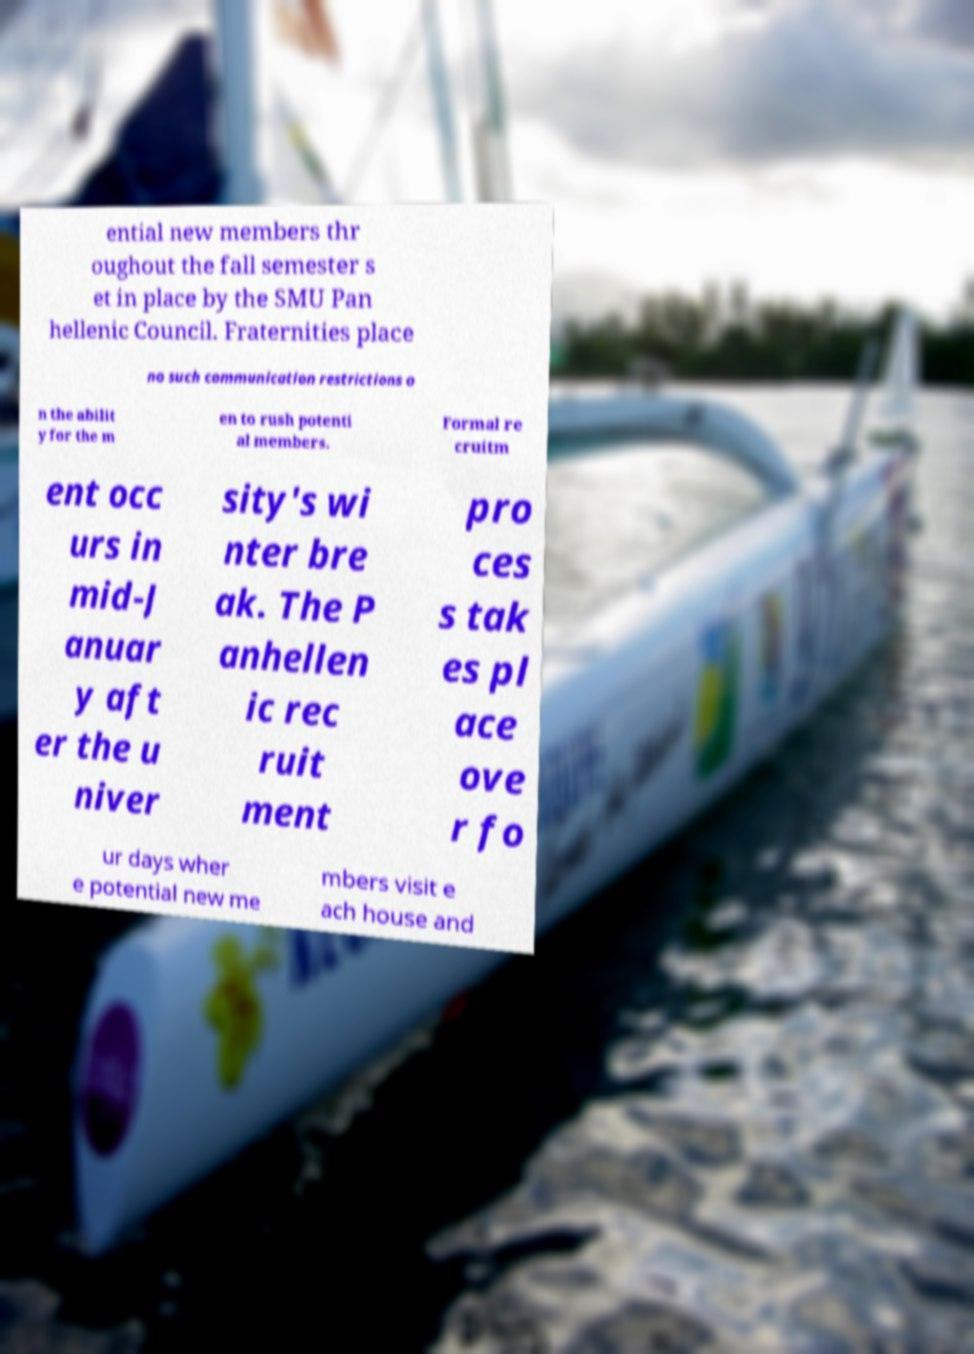Please read and relay the text visible in this image. What does it say? ential new members thr oughout the fall semester s et in place by the SMU Pan hellenic Council. Fraternities place no such communication restrictions o n the abilit y for the m en to rush potenti al members. Formal re cruitm ent occ urs in mid-J anuar y aft er the u niver sity's wi nter bre ak. The P anhellen ic rec ruit ment pro ces s tak es pl ace ove r fo ur days wher e potential new me mbers visit e ach house and 